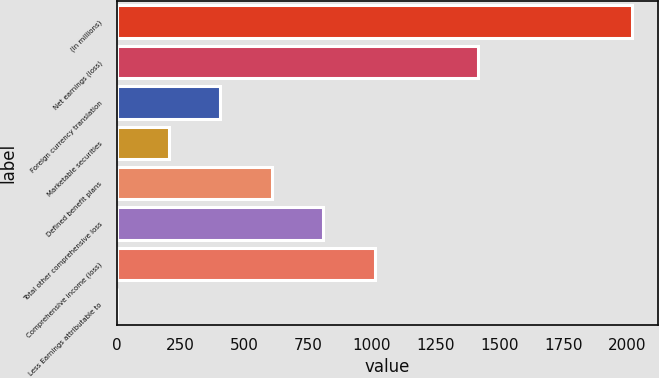Convert chart to OTSL. <chart><loc_0><loc_0><loc_500><loc_500><bar_chart><fcel>(In millions)<fcel>Net earnings (loss)<fcel>Foreign currency translation<fcel>Marketable securities<fcel>Defined benefit plans<fcel>Total other comprehensive loss<fcel>Comprehensive income (loss)<fcel>Less Earnings attributable to<nl><fcel>2018<fcel>1413.5<fcel>406<fcel>204.5<fcel>607.5<fcel>809<fcel>1010.5<fcel>3<nl></chart> 